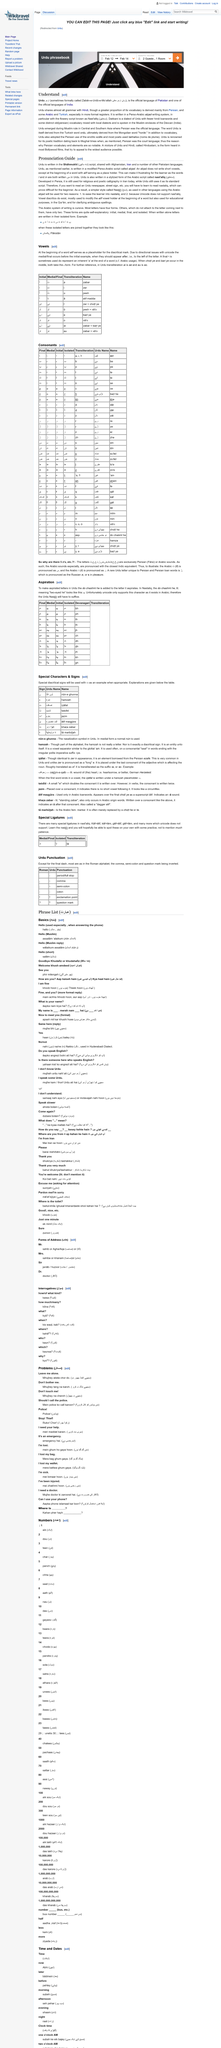List a handful of essential elements in this visual. Urdu is the official language of Pakistan. Urdu is one of the official languages of India and shares almost all of its grammar with Hindi. The alif placed at the beginning of a word is a placeholder that indicates the beginning of the word and its importance in the sentence. The title of this section is the Pronunciation Guide for the French language, which provides a comprehensive guide for accurate pronunciation. The Urdu language is written in the Shahmukhi script. 